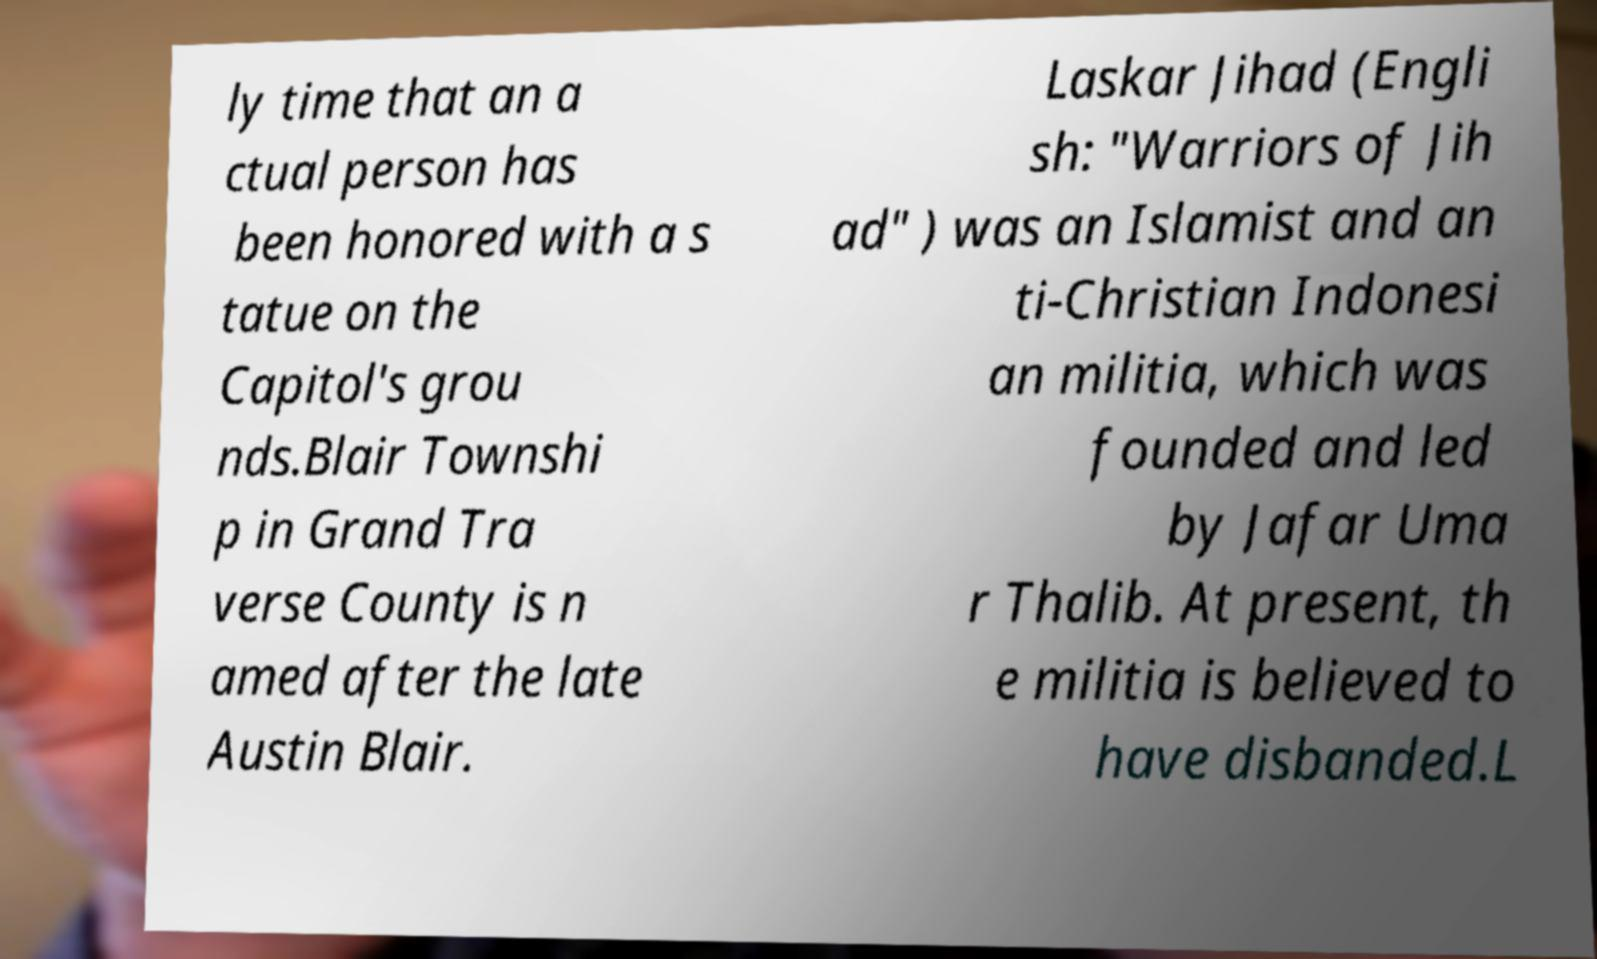Could you assist in decoding the text presented in this image and type it out clearly? ly time that an a ctual person has been honored with a s tatue on the Capitol's grou nds.Blair Townshi p in Grand Tra verse County is n amed after the late Austin Blair. Laskar Jihad (Engli sh: "Warriors of Jih ad" ) was an Islamist and an ti-Christian Indonesi an militia, which was founded and led by Jafar Uma r Thalib. At present, th e militia is believed to have disbanded.L 